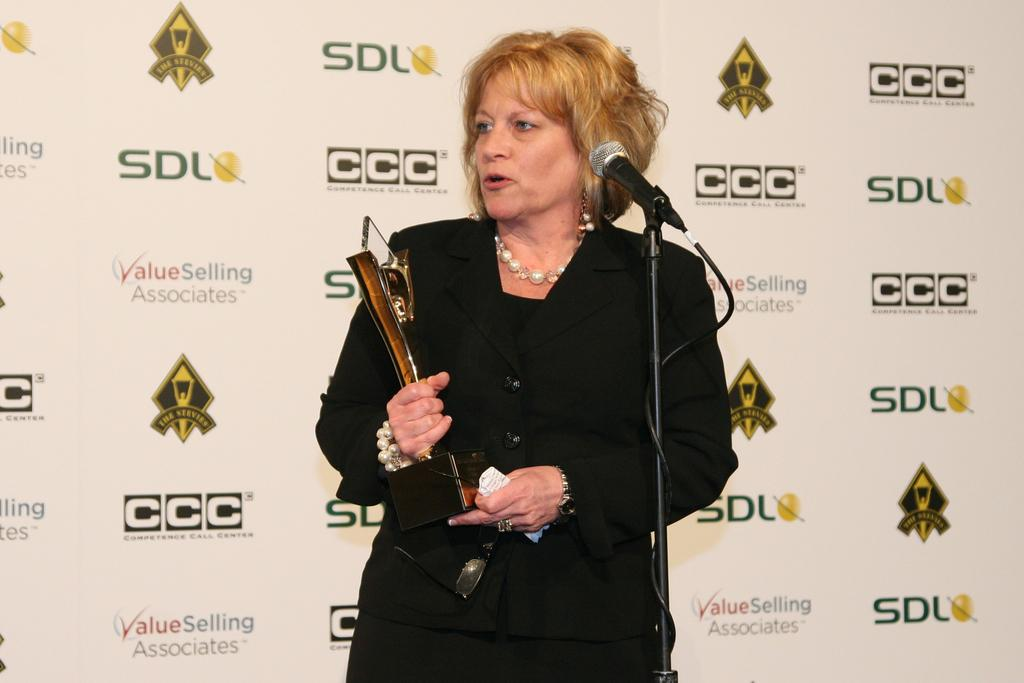Who is the main subject in the image? There is a woman in the image. What is the woman wearing? The woman is wearing a black dress. What is the woman holding in the image? The woman is holding an award. What is the woman doing with the microphone? The woman is talking on a microphone. What can be seen in the background of the image? There is a banner visible in the background. Can you see a coastline in the image? There is no coastline visible in the image; it features a woman holding an award and talking on a microphone. 